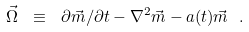Convert formula to latex. <formula><loc_0><loc_0><loc_500><loc_500>\vec { \Omega } \ \equiv \ \partial \vec { m } / \partial t - \nabla ^ { 2 } \vec { m } - a ( t ) \vec { m } \ .</formula> 